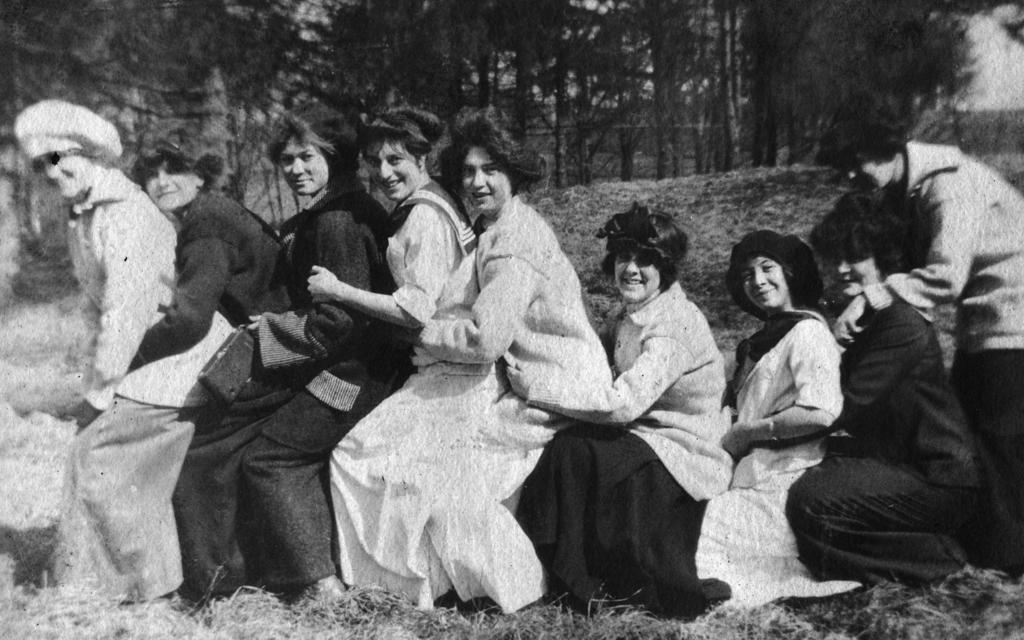What is the color scheme of the image? The image is black and white. Where are the people located in the image? The people are in the center of the image. What type of vegetation is present at the bottom of the image? There is grass at the bottom of the image. What can be seen in the background of the image? There are trees and grass in the background of the image. What type of brass instrument is being played by the people in the image? There is no brass instrument or any musical instrument visible in the image. Where did the people in the image go on vacation? The image does not provide any information about the people's vacation or travel plans. 